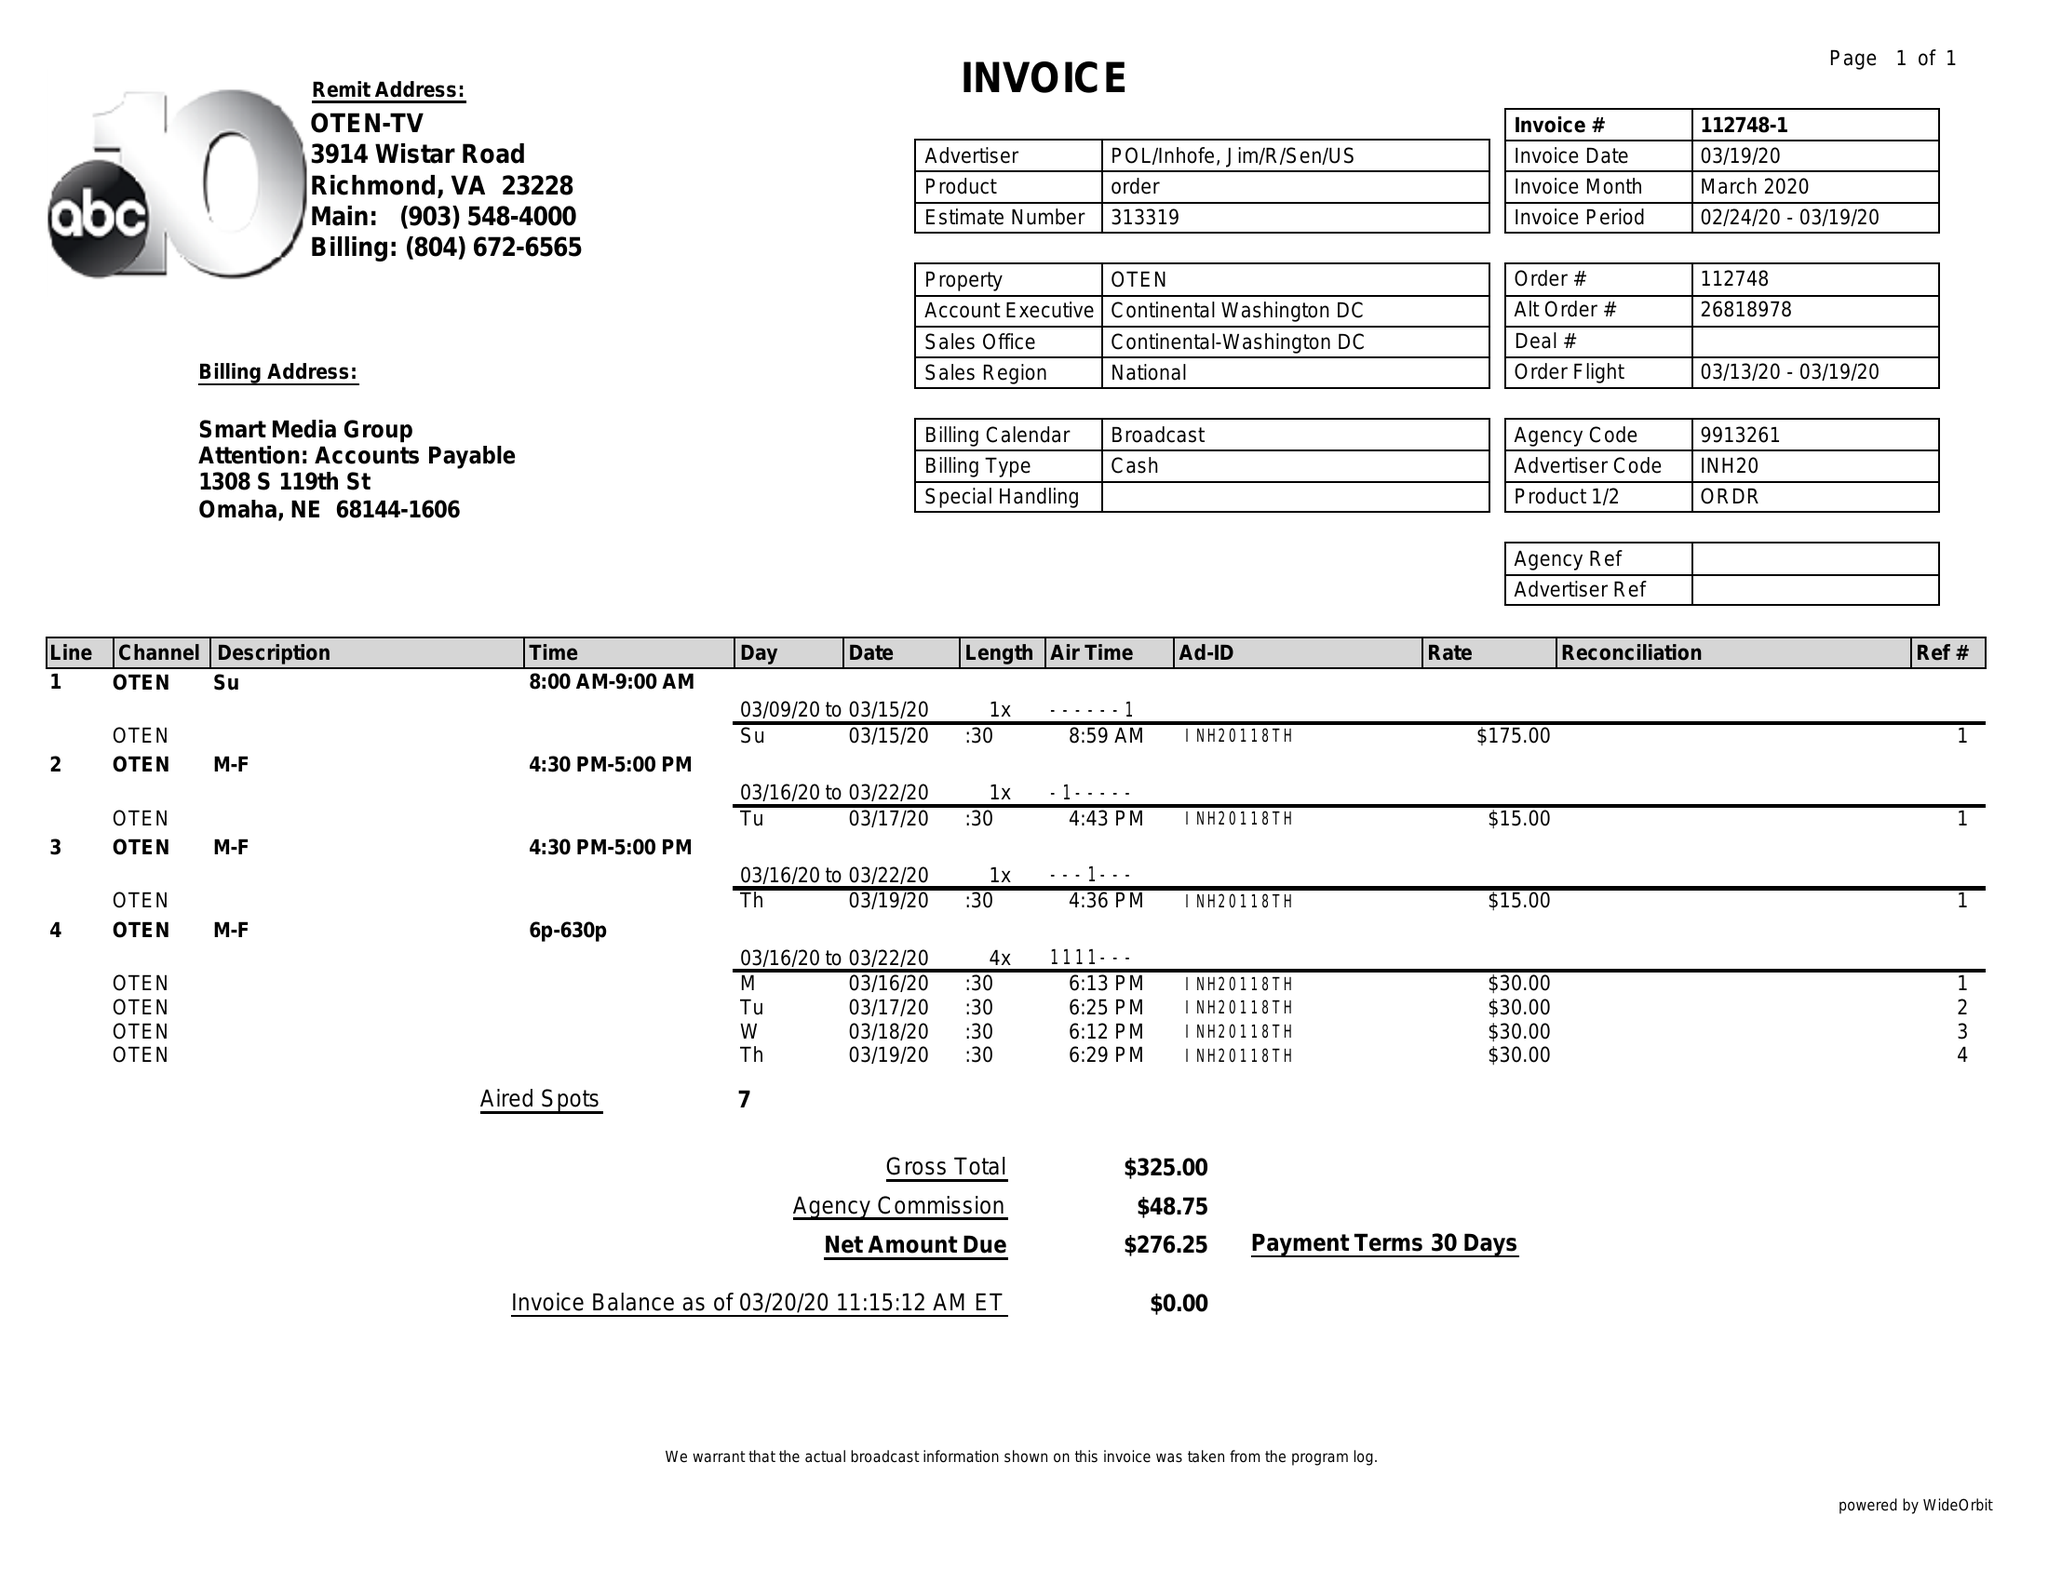What is the value for the advertiser?
Answer the question using a single word or phrase. POL/INHOFE,JIM/R/SEN/US 